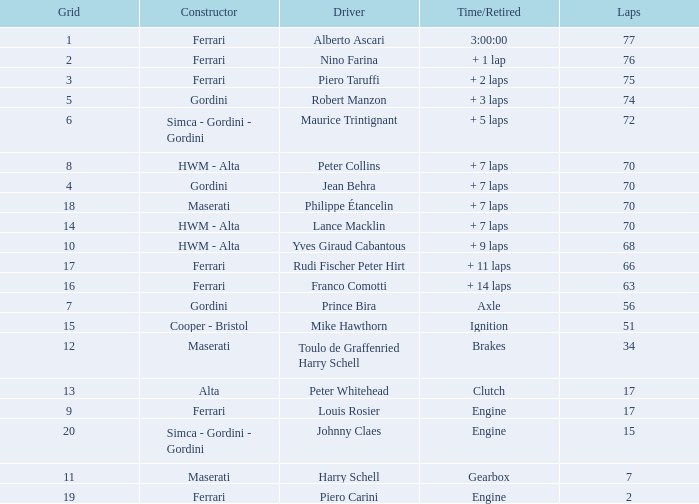What is the high grid for ferrari's with 2 laps? 19.0. 